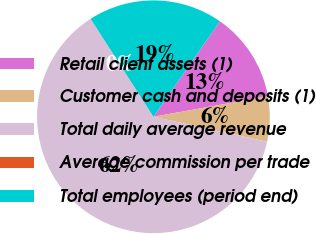Convert chart to OTSL. <chart><loc_0><loc_0><loc_500><loc_500><pie_chart><fcel>Retail client assets (1)<fcel>Customer cash and deposits (1)<fcel>Total daily average revenue<fcel>Average commission per trade<fcel>Total employees (period end)<nl><fcel>12.5%<fcel>6.26%<fcel>62.47%<fcel>0.01%<fcel>18.75%<nl></chart> 